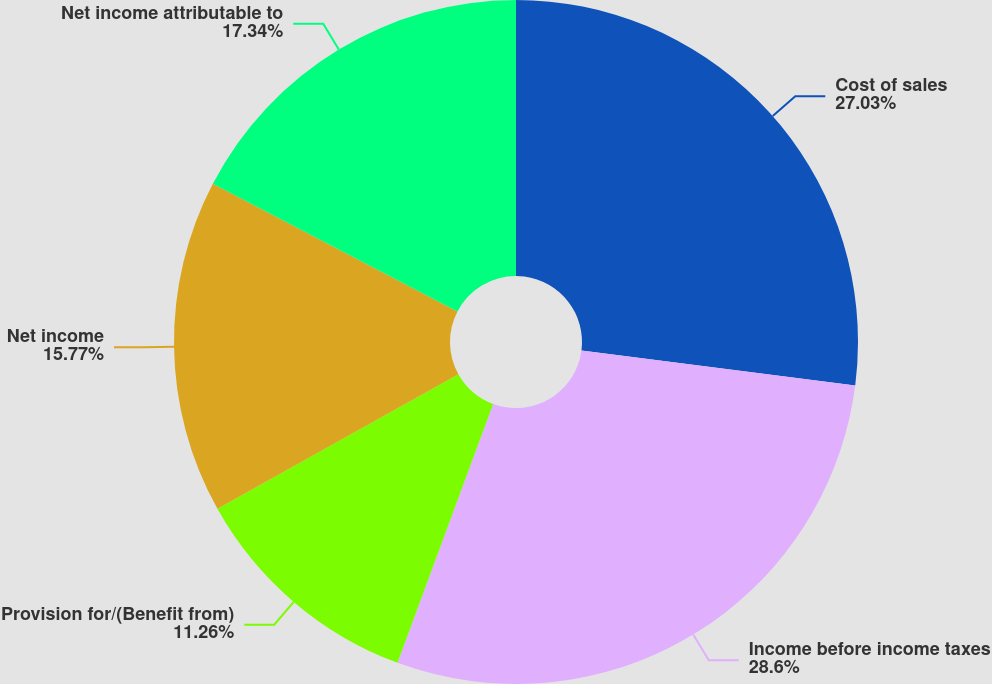<chart> <loc_0><loc_0><loc_500><loc_500><pie_chart><fcel>Cost of sales<fcel>Income before income taxes<fcel>Provision for/(Benefit from)<fcel>Net income<fcel>Net income attributable to<nl><fcel>27.03%<fcel>28.6%<fcel>11.26%<fcel>15.77%<fcel>17.34%<nl></chart> 